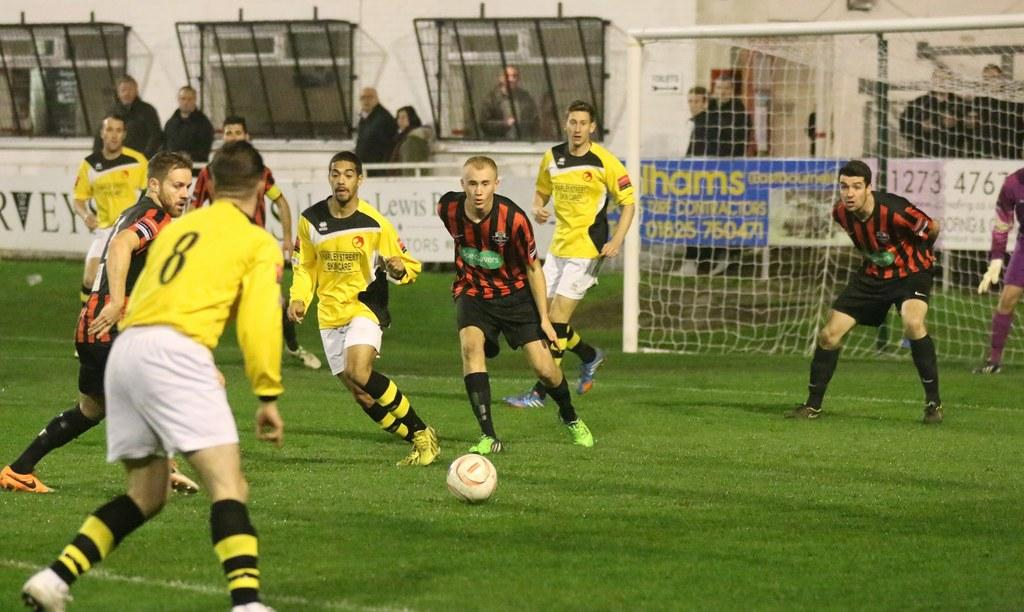<image>
Offer a succinct explanation of the picture presented. soccer players in yellow and white going aginst ones in red and black, number 01825-750471 can be seen behind goal 